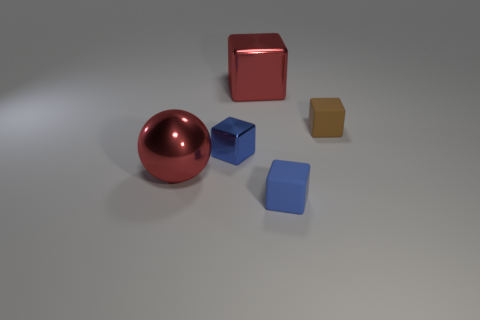Are there fewer large metallic spheres that are in front of the blue rubber block than shiny things left of the large block?
Your answer should be very brief. Yes. Do the tiny brown rubber object and the tiny metal thing have the same shape?
Your answer should be very brief. Yes. What number of other things are there of the same size as the brown matte thing?
Your response must be concise. 2. What number of objects are either large red things behind the ball or big red metal objects that are to the right of the tiny metallic block?
Ensure brevity in your answer.  1. What number of large green metallic objects have the same shape as the small metallic thing?
Your answer should be very brief. 0. What material is the object that is both to the left of the red metallic cube and right of the red metal sphere?
Provide a short and direct response. Metal. There is a small blue metal block; how many large red metallic things are right of it?
Keep it short and to the point. 1. What number of tiny green rubber spheres are there?
Keep it short and to the point. 0. Is the brown rubber thing the same size as the red metal sphere?
Make the answer very short. No. Is there a small cube that is right of the shiny object that is behind the matte object behind the large sphere?
Your answer should be very brief. Yes. 